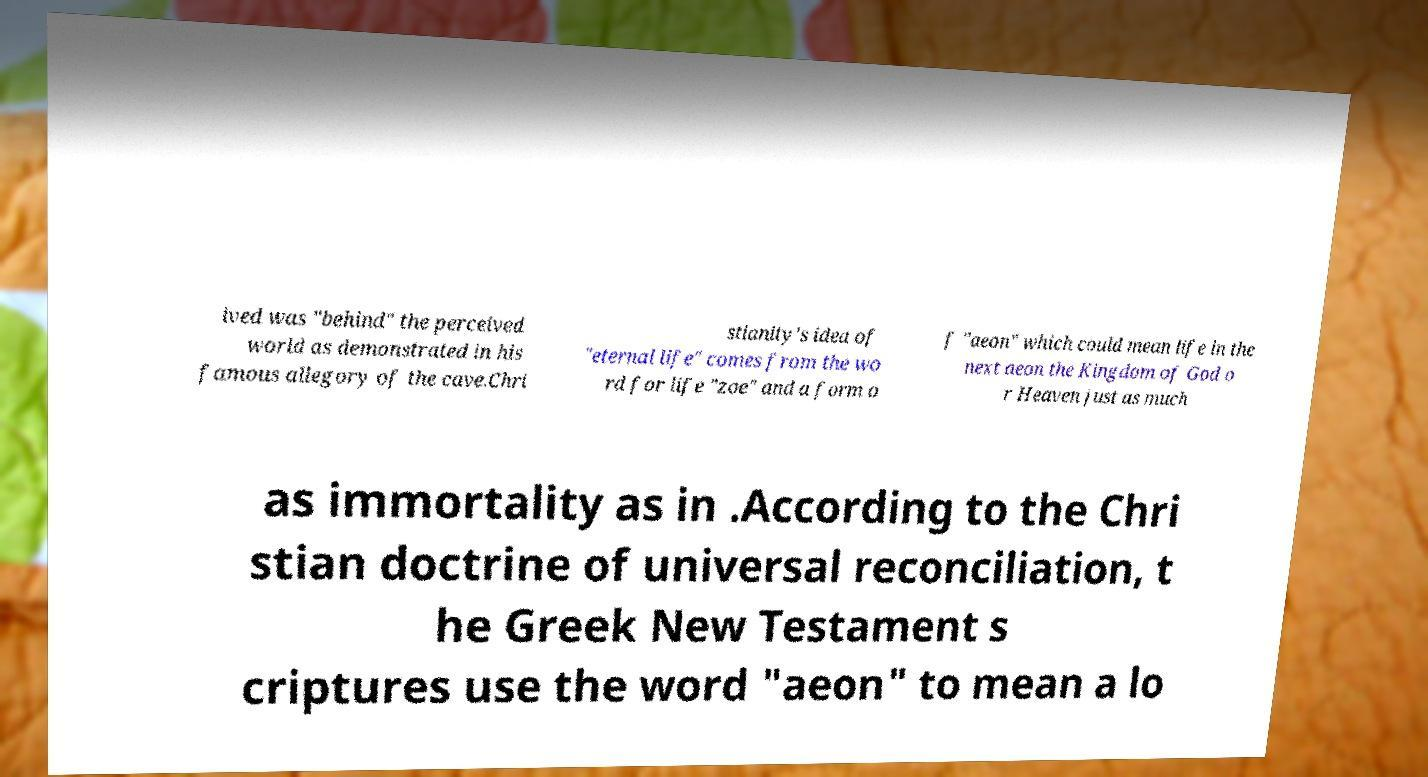Please read and relay the text visible in this image. What does it say? ived was "behind" the perceived world as demonstrated in his famous allegory of the cave.Chri stianity's idea of "eternal life" comes from the wo rd for life "zoe" and a form o f "aeon" which could mean life in the next aeon the Kingdom of God o r Heaven just as much as immortality as in .According to the Chri stian doctrine of universal reconciliation, t he Greek New Testament s criptures use the word "aeon" to mean a lo 